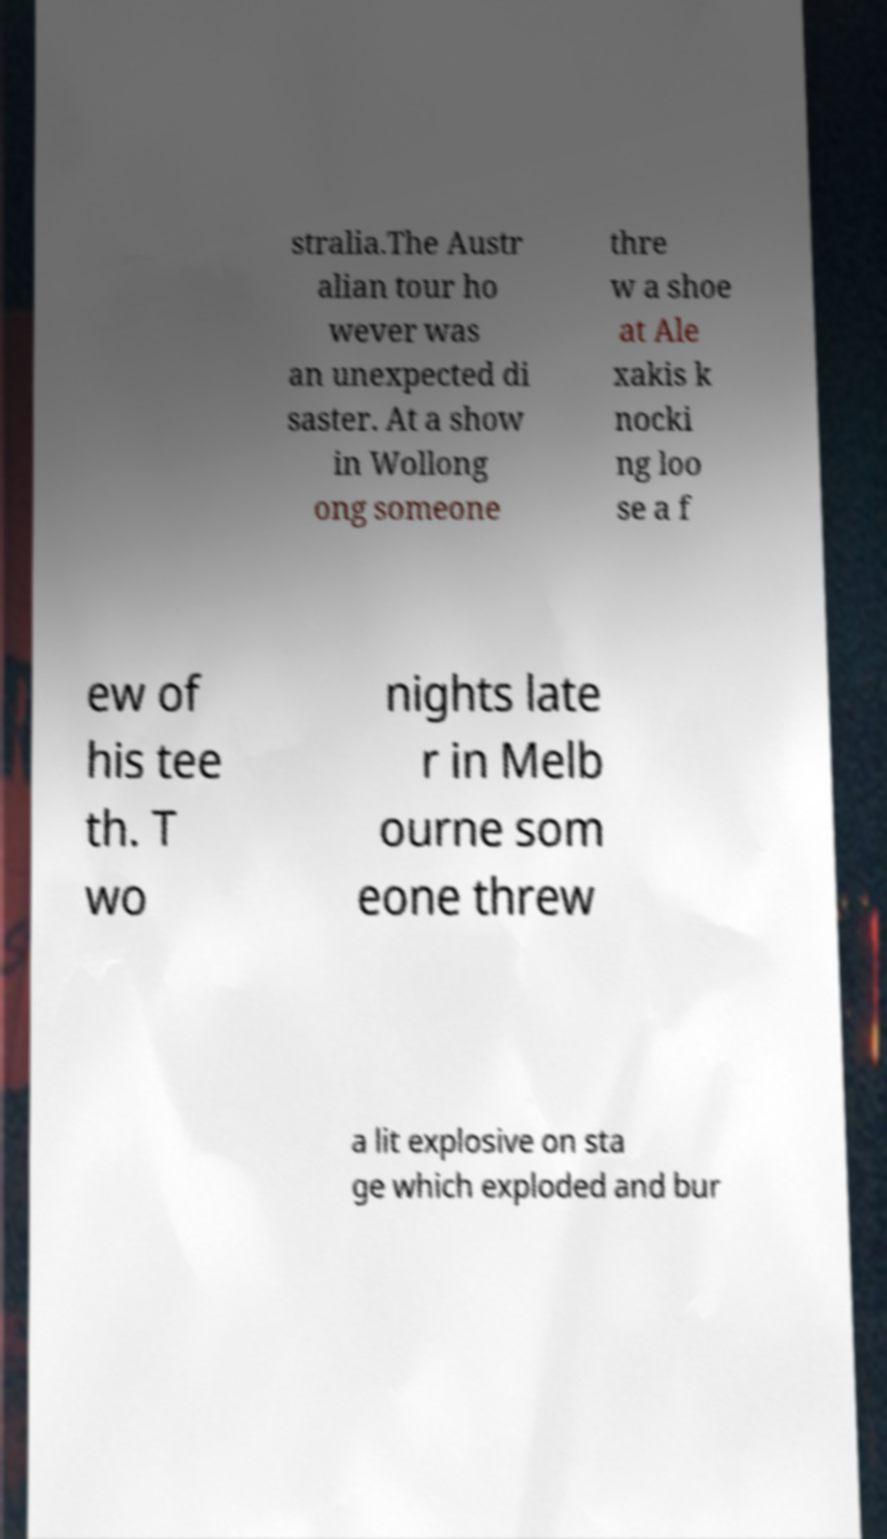For documentation purposes, I need the text within this image transcribed. Could you provide that? stralia.The Austr alian tour ho wever was an unexpected di saster. At a show in Wollong ong someone thre w a shoe at Ale xakis k nocki ng loo se a f ew of his tee th. T wo nights late r in Melb ourne som eone threw a lit explosive on sta ge which exploded and bur 